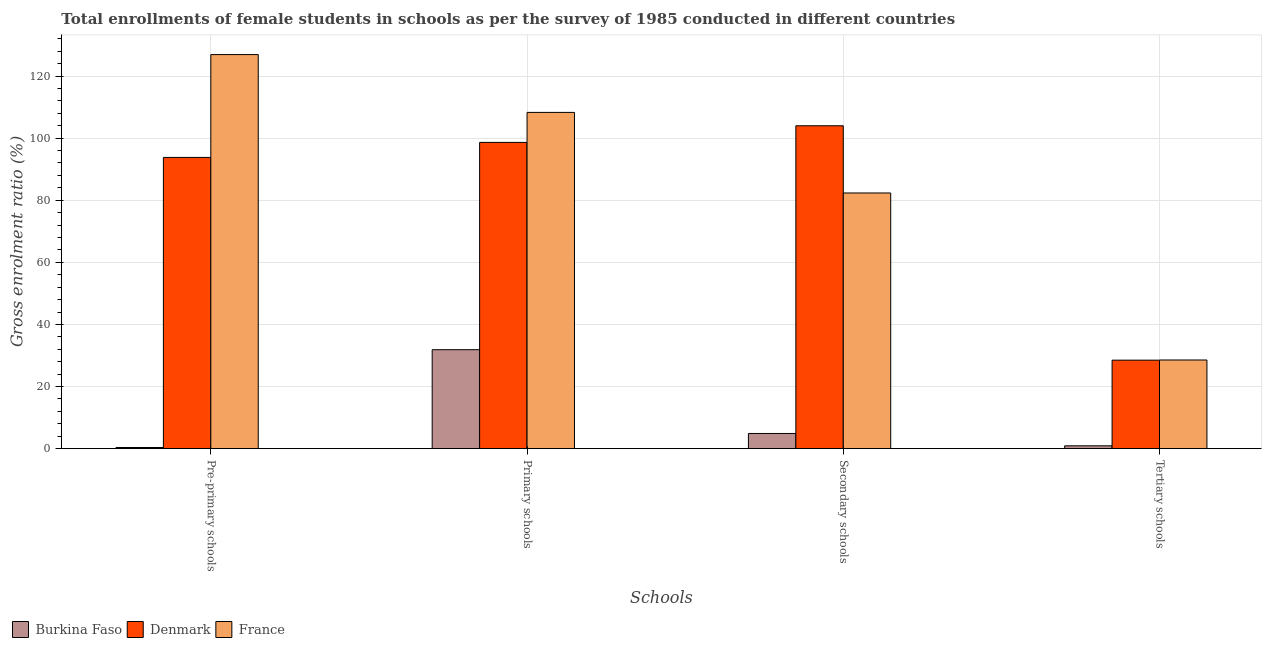How many different coloured bars are there?
Your answer should be compact. 3. Are the number of bars per tick equal to the number of legend labels?
Provide a short and direct response. Yes. How many bars are there on the 1st tick from the right?
Offer a terse response. 3. What is the label of the 2nd group of bars from the left?
Offer a terse response. Primary schools. What is the gross enrolment ratio(female) in tertiary schools in Burkina Faso?
Your response must be concise. 0.92. Across all countries, what is the maximum gross enrolment ratio(female) in primary schools?
Ensure brevity in your answer.  108.29. Across all countries, what is the minimum gross enrolment ratio(female) in secondary schools?
Give a very brief answer. 4.9. In which country was the gross enrolment ratio(female) in primary schools maximum?
Provide a short and direct response. France. In which country was the gross enrolment ratio(female) in primary schools minimum?
Give a very brief answer. Burkina Faso. What is the total gross enrolment ratio(female) in secondary schools in the graph?
Ensure brevity in your answer.  191.22. What is the difference between the gross enrolment ratio(female) in secondary schools in Burkina Faso and that in Denmark?
Offer a very short reply. -99.08. What is the difference between the gross enrolment ratio(female) in secondary schools in Denmark and the gross enrolment ratio(female) in primary schools in France?
Provide a short and direct response. -4.31. What is the average gross enrolment ratio(female) in tertiary schools per country?
Offer a terse response. 19.33. What is the difference between the gross enrolment ratio(female) in secondary schools and gross enrolment ratio(female) in pre-primary schools in Denmark?
Provide a short and direct response. 10.2. What is the ratio of the gross enrolment ratio(female) in pre-primary schools in Denmark to that in France?
Give a very brief answer. 0.74. Is the gross enrolment ratio(female) in primary schools in France less than that in Burkina Faso?
Provide a short and direct response. No. Is the difference between the gross enrolment ratio(female) in pre-primary schools in Burkina Faso and France greater than the difference between the gross enrolment ratio(female) in primary schools in Burkina Faso and France?
Your answer should be compact. No. What is the difference between the highest and the second highest gross enrolment ratio(female) in pre-primary schools?
Your answer should be very brief. 33.12. What is the difference between the highest and the lowest gross enrolment ratio(female) in secondary schools?
Your answer should be very brief. 99.08. What does the 1st bar from the left in Pre-primary schools represents?
Your answer should be compact. Burkina Faso. What does the 3rd bar from the right in Primary schools represents?
Your response must be concise. Burkina Faso. How many bars are there?
Offer a very short reply. 12. Are all the bars in the graph horizontal?
Give a very brief answer. No. What is the difference between two consecutive major ticks on the Y-axis?
Your answer should be compact. 20. What is the title of the graph?
Offer a very short reply. Total enrollments of female students in schools as per the survey of 1985 conducted in different countries. What is the label or title of the X-axis?
Make the answer very short. Schools. What is the label or title of the Y-axis?
Ensure brevity in your answer.  Gross enrolment ratio (%). What is the Gross enrolment ratio (%) of Burkina Faso in Pre-primary schools?
Make the answer very short. 0.38. What is the Gross enrolment ratio (%) of Denmark in Pre-primary schools?
Ensure brevity in your answer.  93.78. What is the Gross enrolment ratio (%) of France in Pre-primary schools?
Make the answer very short. 126.9. What is the Gross enrolment ratio (%) of Burkina Faso in Primary schools?
Provide a succinct answer. 31.87. What is the Gross enrolment ratio (%) in Denmark in Primary schools?
Your answer should be very brief. 98.62. What is the Gross enrolment ratio (%) of France in Primary schools?
Your response must be concise. 108.29. What is the Gross enrolment ratio (%) in Burkina Faso in Secondary schools?
Offer a very short reply. 4.9. What is the Gross enrolment ratio (%) in Denmark in Secondary schools?
Your answer should be compact. 103.98. What is the Gross enrolment ratio (%) in France in Secondary schools?
Your response must be concise. 82.34. What is the Gross enrolment ratio (%) of Burkina Faso in Tertiary schools?
Provide a succinct answer. 0.92. What is the Gross enrolment ratio (%) of Denmark in Tertiary schools?
Your answer should be very brief. 28.5. What is the Gross enrolment ratio (%) of France in Tertiary schools?
Ensure brevity in your answer.  28.56. Across all Schools, what is the maximum Gross enrolment ratio (%) in Burkina Faso?
Your response must be concise. 31.87. Across all Schools, what is the maximum Gross enrolment ratio (%) of Denmark?
Provide a succinct answer. 103.98. Across all Schools, what is the maximum Gross enrolment ratio (%) in France?
Ensure brevity in your answer.  126.9. Across all Schools, what is the minimum Gross enrolment ratio (%) in Burkina Faso?
Provide a succinct answer. 0.38. Across all Schools, what is the minimum Gross enrolment ratio (%) of Denmark?
Provide a short and direct response. 28.5. Across all Schools, what is the minimum Gross enrolment ratio (%) in France?
Make the answer very short. 28.56. What is the total Gross enrolment ratio (%) in Burkina Faso in the graph?
Your response must be concise. 38.07. What is the total Gross enrolment ratio (%) of Denmark in the graph?
Offer a very short reply. 324.89. What is the total Gross enrolment ratio (%) in France in the graph?
Your answer should be compact. 346.09. What is the difference between the Gross enrolment ratio (%) in Burkina Faso in Pre-primary schools and that in Primary schools?
Provide a short and direct response. -31.5. What is the difference between the Gross enrolment ratio (%) in Denmark in Pre-primary schools and that in Primary schools?
Keep it short and to the point. -4.84. What is the difference between the Gross enrolment ratio (%) in France in Pre-primary schools and that in Primary schools?
Your response must be concise. 18.62. What is the difference between the Gross enrolment ratio (%) of Burkina Faso in Pre-primary schools and that in Secondary schools?
Make the answer very short. -4.52. What is the difference between the Gross enrolment ratio (%) of Denmark in Pre-primary schools and that in Secondary schools?
Your answer should be very brief. -10.2. What is the difference between the Gross enrolment ratio (%) in France in Pre-primary schools and that in Secondary schools?
Offer a very short reply. 44.56. What is the difference between the Gross enrolment ratio (%) in Burkina Faso in Pre-primary schools and that in Tertiary schools?
Provide a short and direct response. -0.54. What is the difference between the Gross enrolment ratio (%) of Denmark in Pre-primary schools and that in Tertiary schools?
Offer a very short reply. 65.28. What is the difference between the Gross enrolment ratio (%) in France in Pre-primary schools and that in Tertiary schools?
Give a very brief answer. 98.35. What is the difference between the Gross enrolment ratio (%) in Burkina Faso in Primary schools and that in Secondary schools?
Provide a short and direct response. 26.98. What is the difference between the Gross enrolment ratio (%) in Denmark in Primary schools and that in Secondary schools?
Your response must be concise. -5.36. What is the difference between the Gross enrolment ratio (%) in France in Primary schools and that in Secondary schools?
Keep it short and to the point. 25.95. What is the difference between the Gross enrolment ratio (%) of Burkina Faso in Primary schools and that in Tertiary schools?
Offer a terse response. 30.95. What is the difference between the Gross enrolment ratio (%) in Denmark in Primary schools and that in Tertiary schools?
Your response must be concise. 70.12. What is the difference between the Gross enrolment ratio (%) in France in Primary schools and that in Tertiary schools?
Your answer should be very brief. 79.73. What is the difference between the Gross enrolment ratio (%) in Burkina Faso in Secondary schools and that in Tertiary schools?
Offer a terse response. 3.98. What is the difference between the Gross enrolment ratio (%) in Denmark in Secondary schools and that in Tertiary schools?
Give a very brief answer. 75.48. What is the difference between the Gross enrolment ratio (%) of France in Secondary schools and that in Tertiary schools?
Your response must be concise. 53.78. What is the difference between the Gross enrolment ratio (%) in Burkina Faso in Pre-primary schools and the Gross enrolment ratio (%) in Denmark in Primary schools?
Ensure brevity in your answer.  -98.25. What is the difference between the Gross enrolment ratio (%) of Burkina Faso in Pre-primary schools and the Gross enrolment ratio (%) of France in Primary schools?
Offer a terse response. -107.91. What is the difference between the Gross enrolment ratio (%) in Denmark in Pre-primary schools and the Gross enrolment ratio (%) in France in Primary schools?
Offer a terse response. -14.5. What is the difference between the Gross enrolment ratio (%) in Burkina Faso in Pre-primary schools and the Gross enrolment ratio (%) in Denmark in Secondary schools?
Your response must be concise. -103.6. What is the difference between the Gross enrolment ratio (%) of Burkina Faso in Pre-primary schools and the Gross enrolment ratio (%) of France in Secondary schools?
Give a very brief answer. -81.97. What is the difference between the Gross enrolment ratio (%) of Denmark in Pre-primary schools and the Gross enrolment ratio (%) of France in Secondary schools?
Your answer should be compact. 11.44. What is the difference between the Gross enrolment ratio (%) in Burkina Faso in Pre-primary schools and the Gross enrolment ratio (%) in Denmark in Tertiary schools?
Provide a short and direct response. -28.13. What is the difference between the Gross enrolment ratio (%) of Burkina Faso in Pre-primary schools and the Gross enrolment ratio (%) of France in Tertiary schools?
Provide a succinct answer. -28.18. What is the difference between the Gross enrolment ratio (%) of Denmark in Pre-primary schools and the Gross enrolment ratio (%) of France in Tertiary schools?
Keep it short and to the point. 65.22. What is the difference between the Gross enrolment ratio (%) of Burkina Faso in Primary schools and the Gross enrolment ratio (%) of Denmark in Secondary schools?
Give a very brief answer. -72.11. What is the difference between the Gross enrolment ratio (%) in Burkina Faso in Primary schools and the Gross enrolment ratio (%) in France in Secondary schools?
Offer a very short reply. -50.47. What is the difference between the Gross enrolment ratio (%) of Denmark in Primary schools and the Gross enrolment ratio (%) of France in Secondary schools?
Keep it short and to the point. 16.28. What is the difference between the Gross enrolment ratio (%) in Burkina Faso in Primary schools and the Gross enrolment ratio (%) in Denmark in Tertiary schools?
Offer a terse response. 3.37. What is the difference between the Gross enrolment ratio (%) of Burkina Faso in Primary schools and the Gross enrolment ratio (%) of France in Tertiary schools?
Your response must be concise. 3.31. What is the difference between the Gross enrolment ratio (%) in Denmark in Primary schools and the Gross enrolment ratio (%) in France in Tertiary schools?
Offer a very short reply. 70.06. What is the difference between the Gross enrolment ratio (%) of Burkina Faso in Secondary schools and the Gross enrolment ratio (%) of Denmark in Tertiary schools?
Your response must be concise. -23.61. What is the difference between the Gross enrolment ratio (%) in Burkina Faso in Secondary schools and the Gross enrolment ratio (%) in France in Tertiary schools?
Give a very brief answer. -23.66. What is the difference between the Gross enrolment ratio (%) of Denmark in Secondary schools and the Gross enrolment ratio (%) of France in Tertiary schools?
Your answer should be very brief. 75.42. What is the average Gross enrolment ratio (%) of Burkina Faso per Schools?
Give a very brief answer. 9.52. What is the average Gross enrolment ratio (%) in Denmark per Schools?
Provide a succinct answer. 81.22. What is the average Gross enrolment ratio (%) of France per Schools?
Your answer should be compact. 86.52. What is the difference between the Gross enrolment ratio (%) of Burkina Faso and Gross enrolment ratio (%) of Denmark in Pre-primary schools?
Provide a succinct answer. -93.41. What is the difference between the Gross enrolment ratio (%) of Burkina Faso and Gross enrolment ratio (%) of France in Pre-primary schools?
Offer a terse response. -126.53. What is the difference between the Gross enrolment ratio (%) in Denmark and Gross enrolment ratio (%) in France in Pre-primary schools?
Keep it short and to the point. -33.12. What is the difference between the Gross enrolment ratio (%) in Burkina Faso and Gross enrolment ratio (%) in Denmark in Primary schools?
Give a very brief answer. -66.75. What is the difference between the Gross enrolment ratio (%) in Burkina Faso and Gross enrolment ratio (%) in France in Primary schools?
Your answer should be very brief. -76.41. What is the difference between the Gross enrolment ratio (%) of Denmark and Gross enrolment ratio (%) of France in Primary schools?
Your answer should be very brief. -9.66. What is the difference between the Gross enrolment ratio (%) of Burkina Faso and Gross enrolment ratio (%) of Denmark in Secondary schools?
Your answer should be compact. -99.08. What is the difference between the Gross enrolment ratio (%) of Burkina Faso and Gross enrolment ratio (%) of France in Secondary schools?
Provide a short and direct response. -77.45. What is the difference between the Gross enrolment ratio (%) in Denmark and Gross enrolment ratio (%) in France in Secondary schools?
Keep it short and to the point. 21.64. What is the difference between the Gross enrolment ratio (%) in Burkina Faso and Gross enrolment ratio (%) in Denmark in Tertiary schools?
Provide a short and direct response. -27.58. What is the difference between the Gross enrolment ratio (%) in Burkina Faso and Gross enrolment ratio (%) in France in Tertiary schools?
Give a very brief answer. -27.64. What is the difference between the Gross enrolment ratio (%) in Denmark and Gross enrolment ratio (%) in France in Tertiary schools?
Offer a terse response. -0.06. What is the ratio of the Gross enrolment ratio (%) in Burkina Faso in Pre-primary schools to that in Primary schools?
Ensure brevity in your answer.  0.01. What is the ratio of the Gross enrolment ratio (%) of Denmark in Pre-primary schools to that in Primary schools?
Keep it short and to the point. 0.95. What is the ratio of the Gross enrolment ratio (%) in France in Pre-primary schools to that in Primary schools?
Ensure brevity in your answer.  1.17. What is the ratio of the Gross enrolment ratio (%) of Burkina Faso in Pre-primary schools to that in Secondary schools?
Make the answer very short. 0.08. What is the ratio of the Gross enrolment ratio (%) of Denmark in Pre-primary schools to that in Secondary schools?
Give a very brief answer. 0.9. What is the ratio of the Gross enrolment ratio (%) of France in Pre-primary schools to that in Secondary schools?
Ensure brevity in your answer.  1.54. What is the ratio of the Gross enrolment ratio (%) of Burkina Faso in Pre-primary schools to that in Tertiary schools?
Ensure brevity in your answer.  0.41. What is the ratio of the Gross enrolment ratio (%) in Denmark in Pre-primary schools to that in Tertiary schools?
Your answer should be very brief. 3.29. What is the ratio of the Gross enrolment ratio (%) in France in Pre-primary schools to that in Tertiary schools?
Provide a short and direct response. 4.44. What is the ratio of the Gross enrolment ratio (%) of Burkina Faso in Primary schools to that in Secondary schools?
Offer a very short reply. 6.51. What is the ratio of the Gross enrolment ratio (%) of Denmark in Primary schools to that in Secondary schools?
Provide a short and direct response. 0.95. What is the ratio of the Gross enrolment ratio (%) of France in Primary schools to that in Secondary schools?
Make the answer very short. 1.32. What is the ratio of the Gross enrolment ratio (%) in Burkina Faso in Primary schools to that in Tertiary schools?
Your response must be concise. 34.66. What is the ratio of the Gross enrolment ratio (%) in Denmark in Primary schools to that in Tertiary schools?
Keep it short and to the point. 3.46. What is the ratio of the Gross enrolment ratio (%) in France in Primary schools to that in Tertiary schools?
Your answer should be very brief. 3.79. What is the ratio of the Gross enrolment ratio (%) in Burkina Faso in Secondary schools to that in Tertiary schools?
Provide a short and direct response. 5.32. What is the ratio of the Gross enrolment ratio (%) in Denmark in Secondary schools to that in Tertiary schools?
Give a very brief answer. 3.65. What is the ratio of the Gross enrolment ratio (%) of France in Secondary schools to that in Tertiary schools?
Ensure brevity in your answer.  2.88. What is the difference between the highest and the second highest Gross enrolment ratio (%) of Burkina Faso?
Your response must be concise. 26.98. What is the difference between the highest and the second highest Gross enrolment ratio (%) of Denmark?
Your response must be concise. 5.36. What is the difference between the highest and the second highest Gross enrolment ratio (%) in France?
Make the answer very short. 18.62. What is the difference between the highest and the lowest Gross enrolment ratio (%) in Burkina Faso?
Keep it short and to the point. 31.5. What is the difference between the highest and the lowest Gross enrolment ratio (%) in Denmark?
Give a very brief answer. 75.48. What is the difference between the highest and the lowest Gross enrolment ratio (%) of France?
Your answer should be very brief. 98.35. 